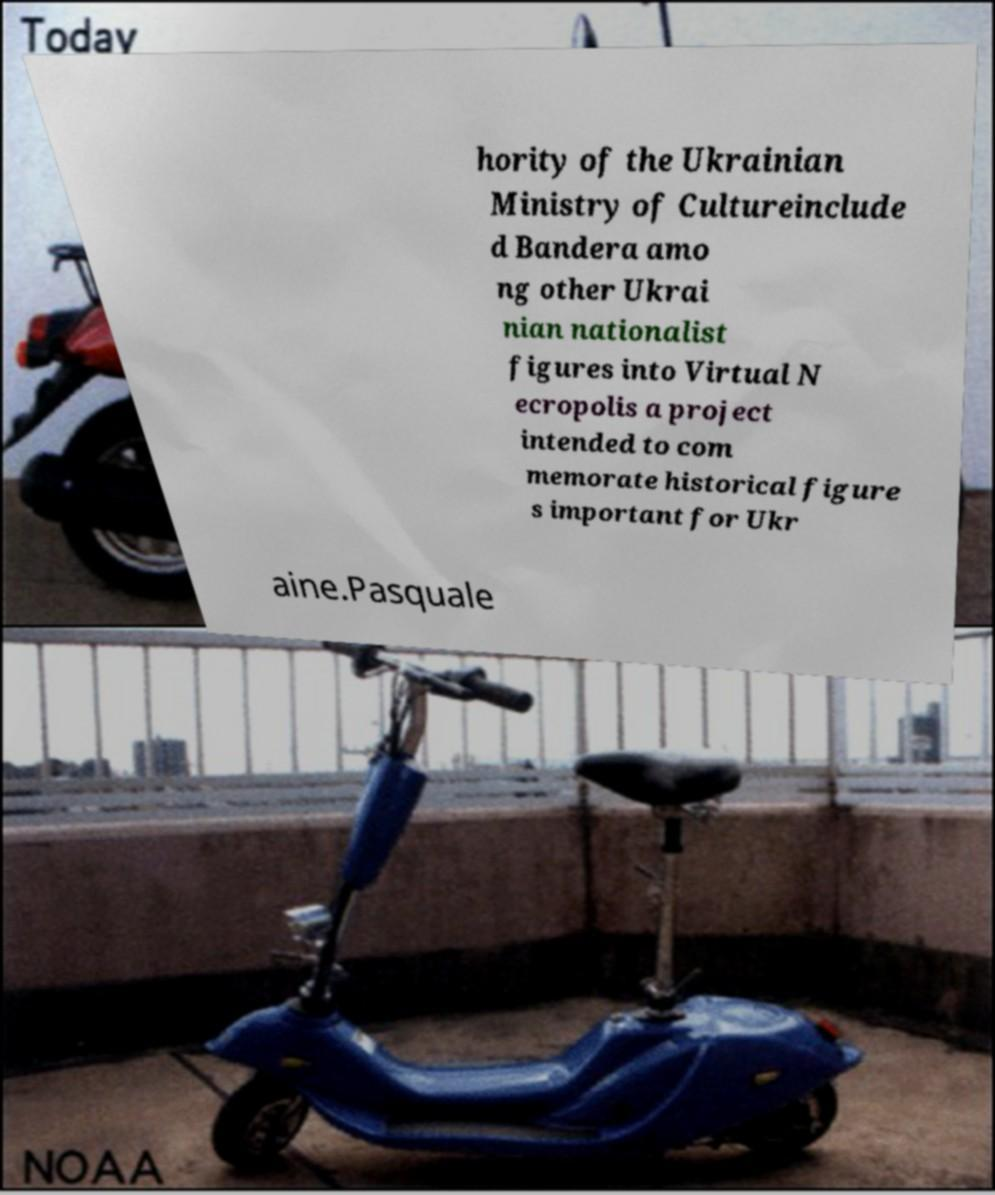What messages or text are displayed in this image? I need them in a readable, typed format. hority of the Ukrainian Ministry of Cultureinclude d Bandera amo ng other Ukrai nian nationalist figures into Virtual N ecropolis a project intended to com memorate historical figure s important for Ukr aine.Pasquale 